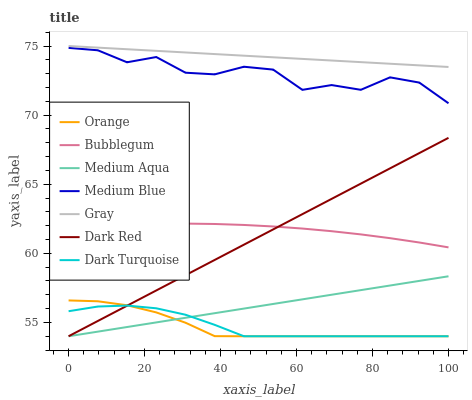Does Orange have the minimum area under the curve?
Answer yes or no. Yes. Does Gray have the maximum area under the curve?
Answer yes or no. Yes. Does Dark Red have the minimum area under the curve?
Answer yes or no. No. Does Dark Red have the maximum area under the curve?
Answer yes or no. No. Is Medium Aqua the smoothest?
Answer yes or no. Yes. Is Medium Blue the roughest?
Answer yes or no. Yes. Is Dark Red the smoothest?
Answer yes or no. No. Is Dark Red the roughest?
Answer yes or no. No. Does Dark Red have the lowest value?
Answer yes or no. Yes. Does Medium Blue have the lowest value?
Answer yes or no. No. Does Gray have the highest value?
Answer yes or no. Yes. Does Dark Red have the highest value?
Answer yes or no. No. Is Bubblegum less than Medium Blue?
Answer yes or no. Yes. Is Gray greater than Orange?
Answer yes or no. Yes. Does Medium Aqua intersect Dark Red?
Answer yes or no. Yes. Is Medium Aqua less than Dark Red?
Answer yes or no. No. Is Medium Aqua greater than Dark Red?
Answer yes or no. No. Does Bubblegum intersect Medium Blue?
Answer yes or no. No. 